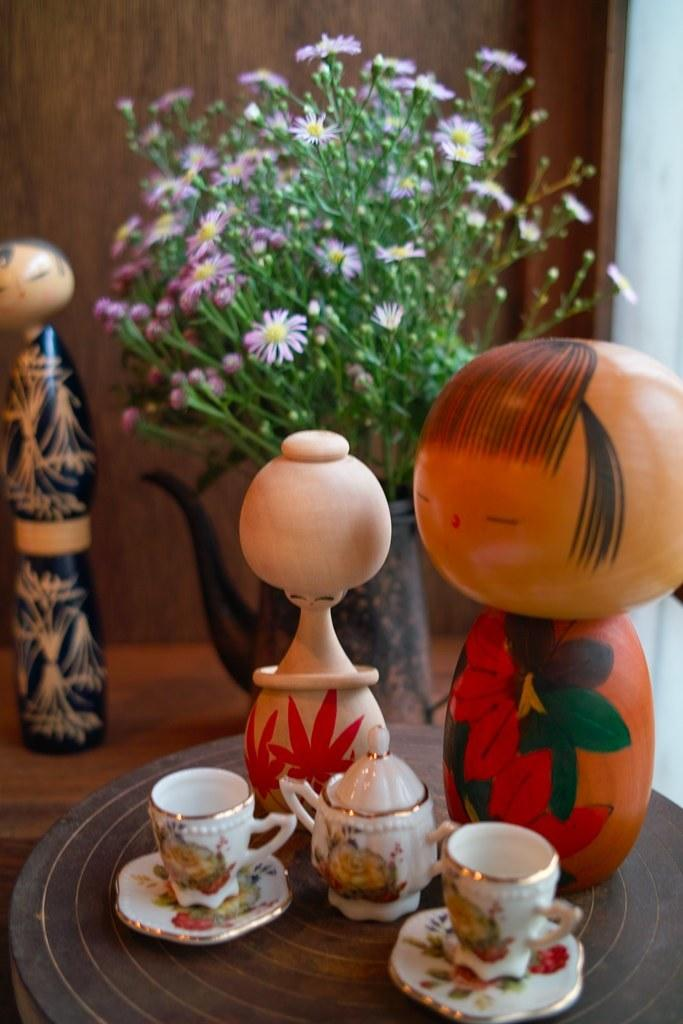What is located at the bottom of the image? There is a table at the bottom of the image. What items can be seen on the table? There are cups, saucers, and decorative items on the table. Is there any vegetation visible in the image? Yes, there is a plant visible behind the table. What is behind the table? There is a wall behind the table. Who is the owner of the tub in the image? There is no tub present in the image. 